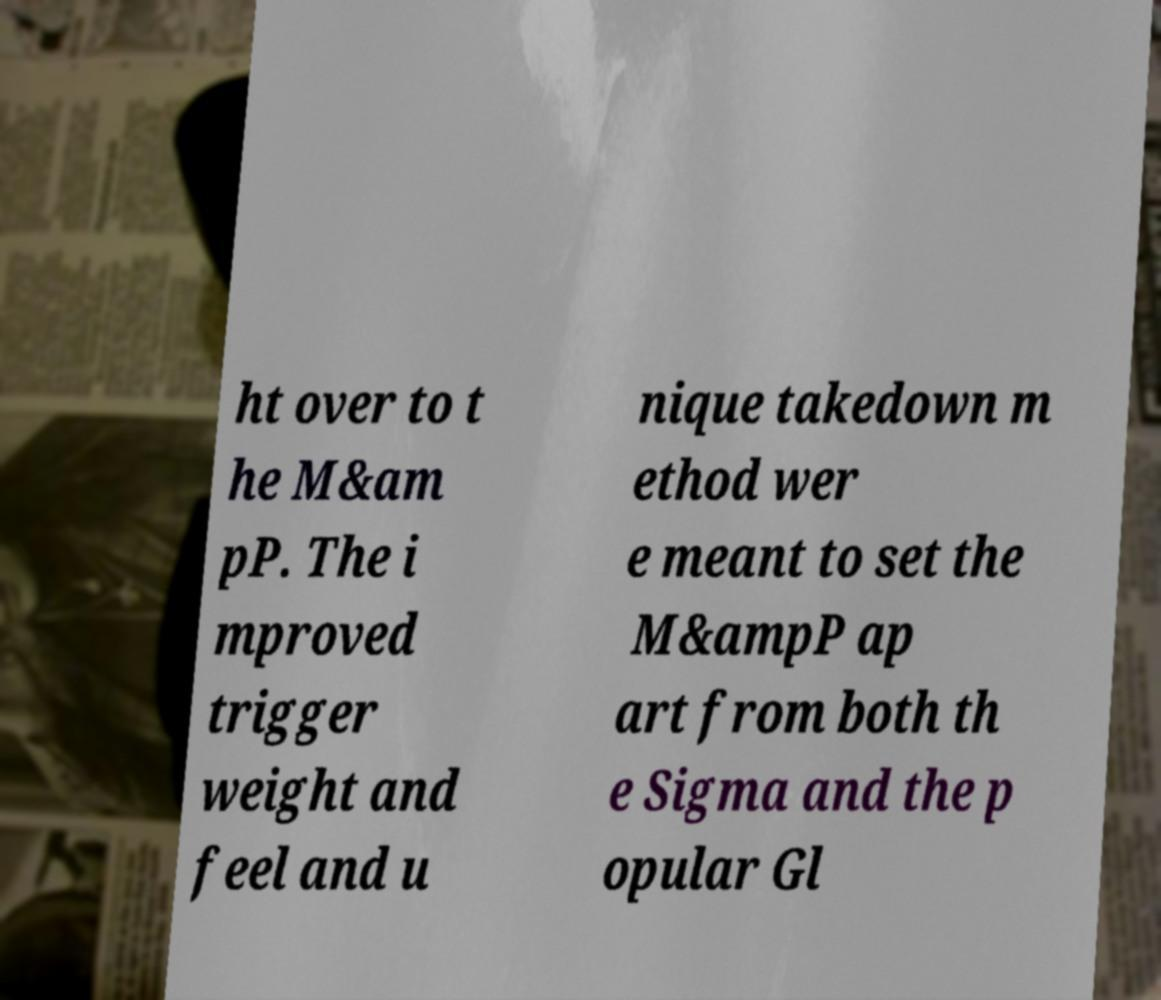Can you accurately transcribe the text from the provided image for me? ht over to t he M&am pP. The i mproved trigger weight and feel and u nique takedown m ethod wer e meant to set the M&ampP ap art from both th e Sigma and the p opular Gl 